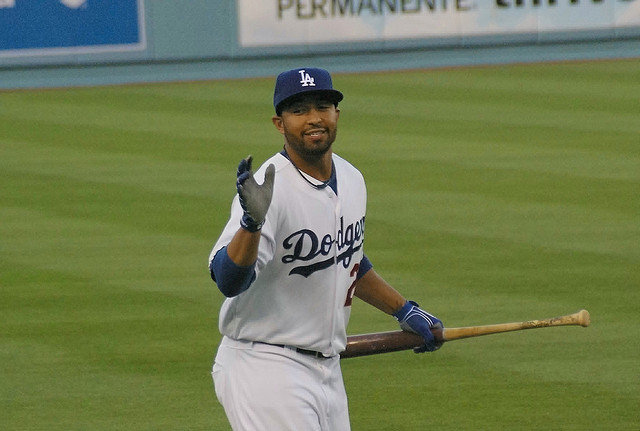<image>What is the name of this baseball player? I don't know the name of the baseball player. What is the name of this baseball player? I don't know the name of this baseball player. It can be any of 'dodgers', 'man', 'morris', 'jeter', 'ramirez' or 'roger'. 